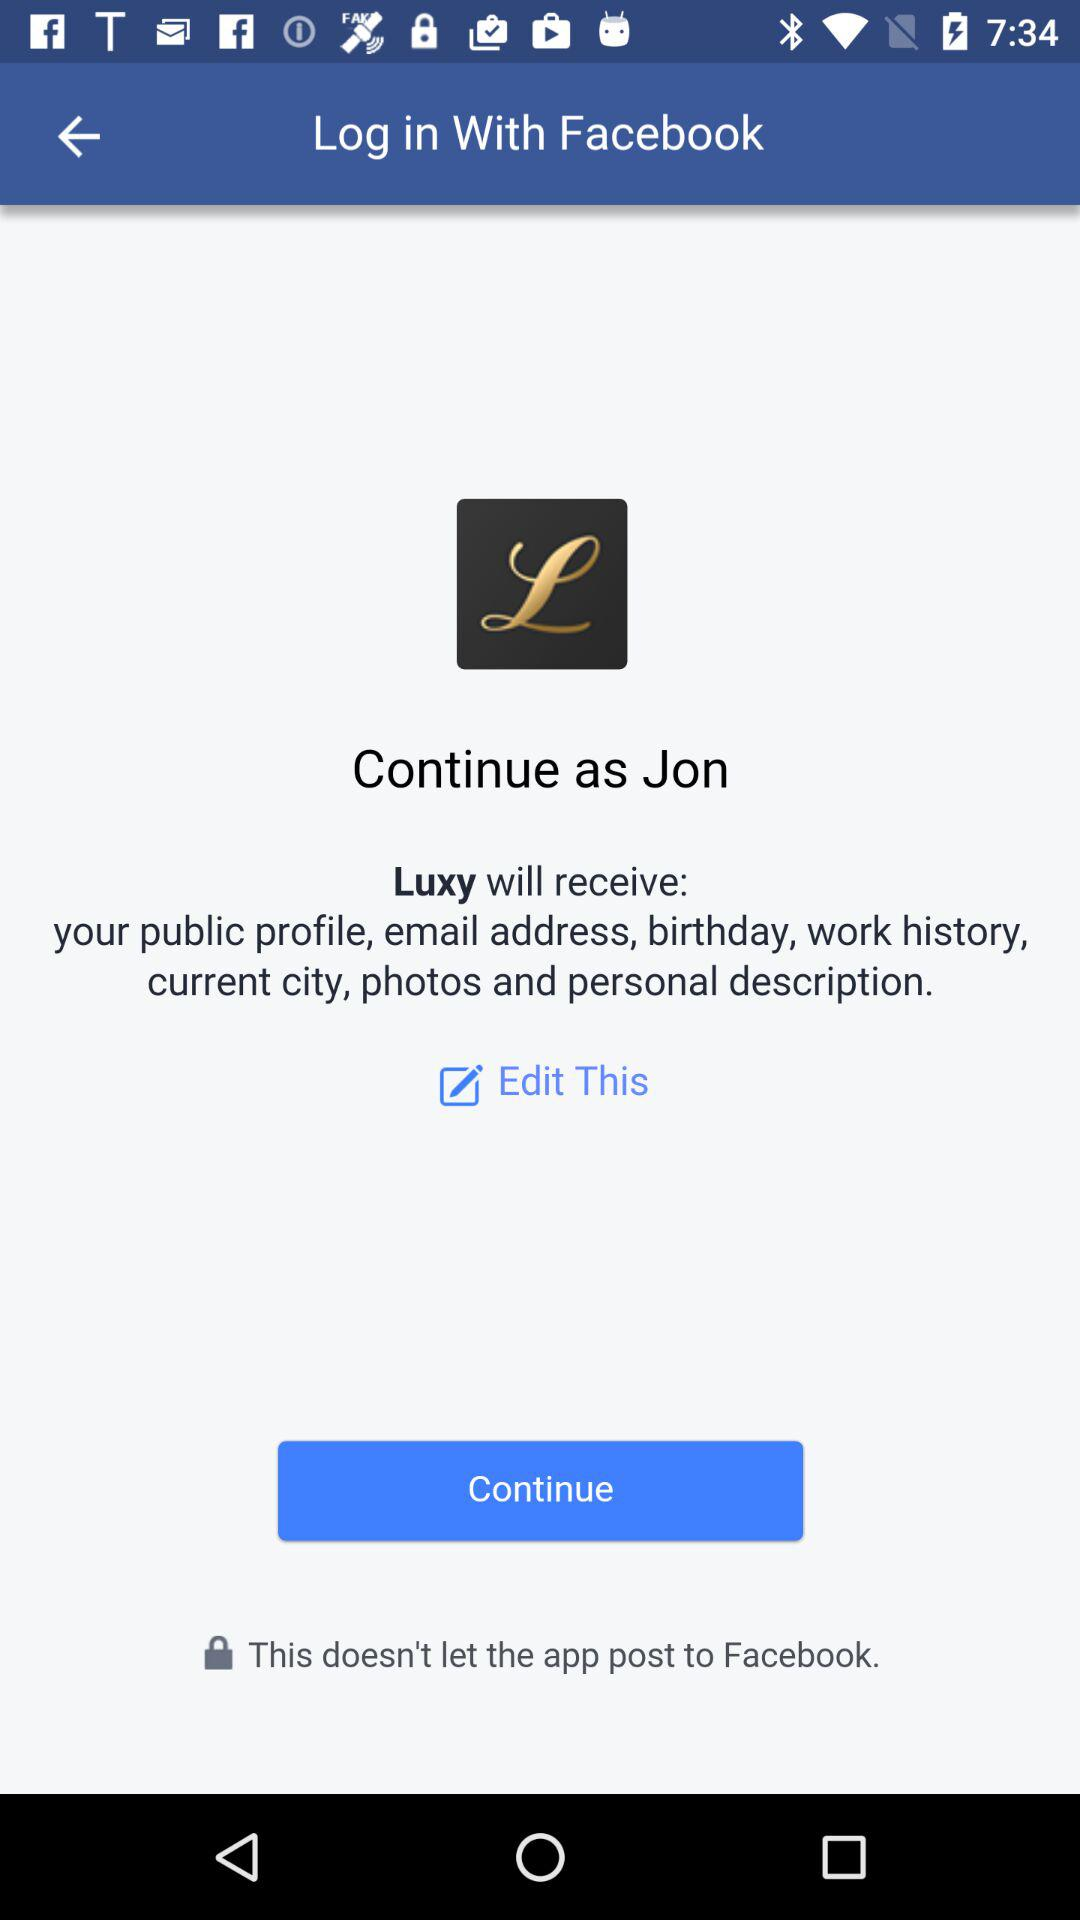What is the user name? The user name is Jon. 